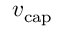Convert formula to latex. <formula><loc_0><loc_0><loc_500><loc_500>{ v _ { c a p } }</formula> 